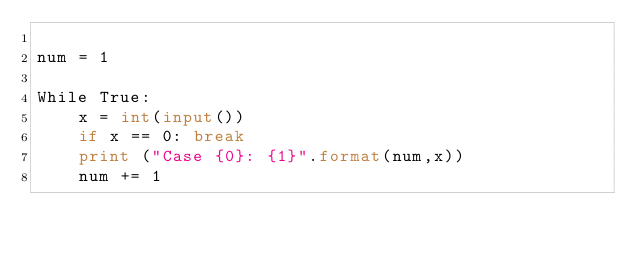<code> <loc_0><loc_0><loc_500><loc_500><_Python_>
num = 1

While True:
    x = int(input())
    if x == 0: break
    print ("Case {0}: {1}".format(num,x))
    num += 1
</code> 